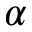<formula> <loc_0><loc_0><loc_500><loc_500>\alpha</formula> 